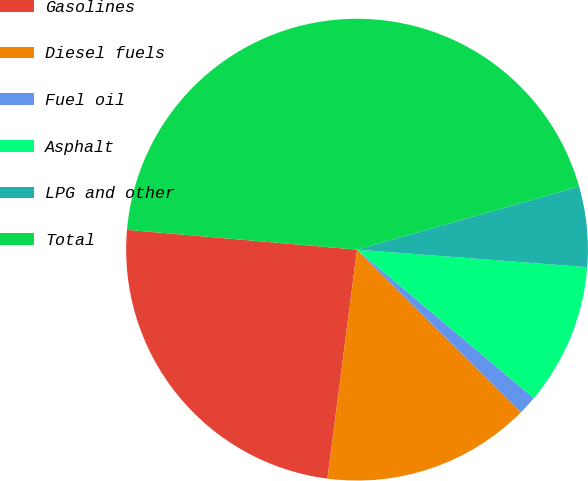<chart> <loc_0><loc_0><loc_500><loc_500><pie_chart><fcel>Gasolines<fcel>Diesel fuels<fcel>Fuel oil<fcel>Asphalt<fcel>LPG and other<fcel>Total<nl><fcel>24.33%<fcel>14.6%<fcel>1.33%<fcel>9.91%<fcel>5.62%<fcel>44.23%<nl></chart> 